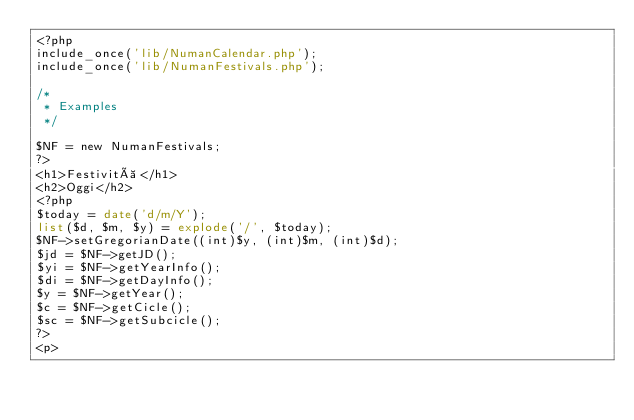Convert code to text. <code><loc_0><loc_0><loc_500><loc_500><_PHP_><?php
include_once('lib/NumanCalendar.php');
include_once('lib/NumanFestivals.php');

/* 
 * Examples
 */

$NF = new NumanFestivals;
?>
<h1>Festività</h1>
<h2>Oggi</h2>
<?php
$today = date('d/m/Y');
list($d, $m, $y) = explode('/', $today);
$NF->setGregorianDate((int)$y, (int)$m, (int)$d);
$jd = $NF->getJD();
$yi = $NF->getYearInfo();
$di = $NF->getDayInfo();
$y = $NF->getYear();
$c = $NF->getCicle();
$sc = $NF->getSubcicle();
?>
<p></code> 